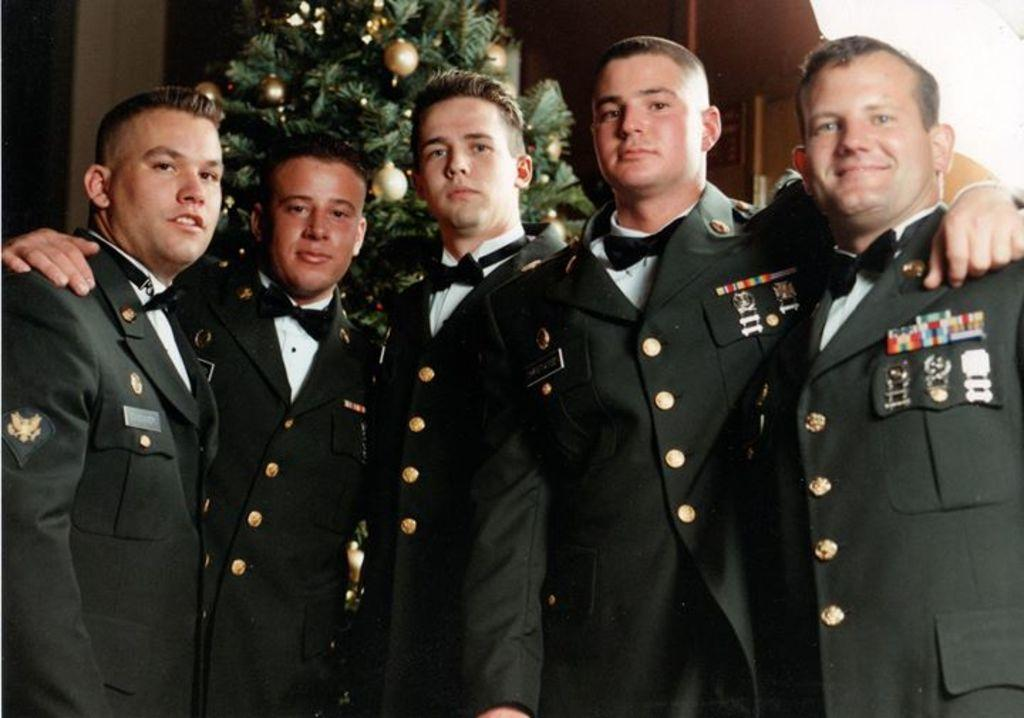What can be observed about the people in the image? There are people standing in the image, and they are wearing uniforms. What is visible in the background of the image? There is an xmas tree and a wall in the background of the image. What type of liquid is being used to rake the purpose of the uniforms in the image? There is no liquid or rake present in the image, and the purpose of the uniforms is not mentioned. 